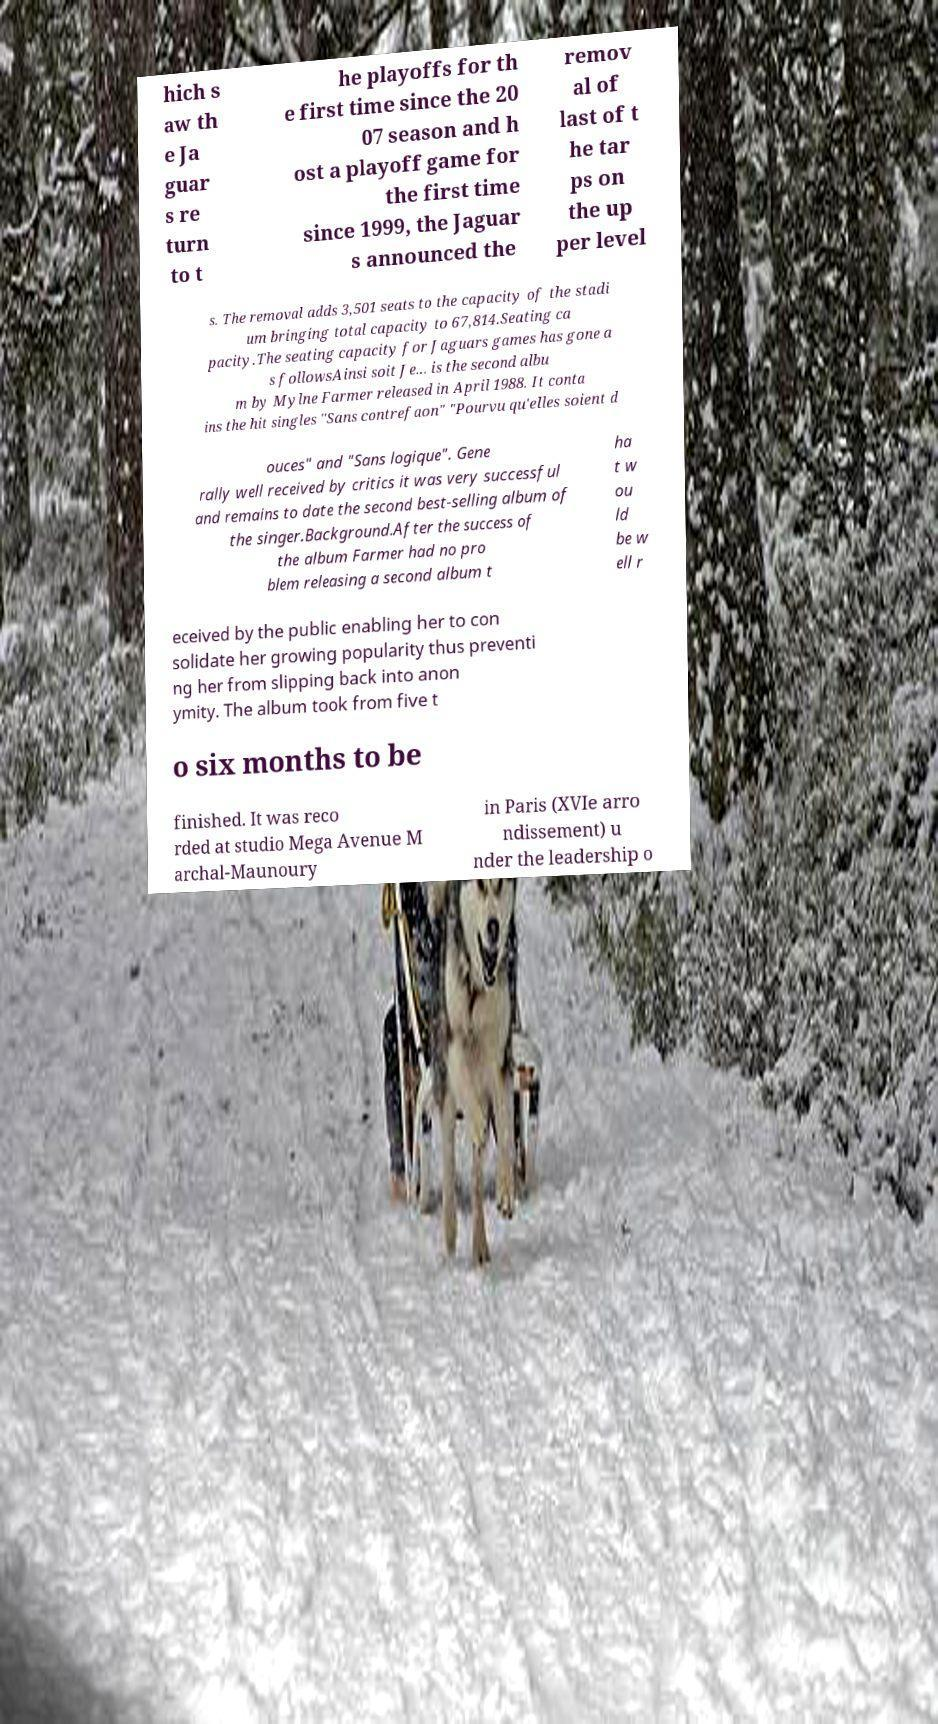Could you assist in decoding the text presented in this image and type it out clearly? hich s aw th e Ja guar s re turn to t he playoffs for th e first time since the 20 07 season and h ost a playoff game for the first time since 1999, the Jaguar s announced the remov al of last of t he tar ps on the up per level s. The removal adds 3,501 seats to the capacity of the stadi um bringing total capacity to 67,814.Seating ca pacity.The seating capacity for Jaguars games has gone a s followsAinsi soit Je... is the second albu m by Mylne Farmer released in April 1988. It conta ins the hit singles "Sans contrefaon" "Pourvu qu'elles soient d ouces" and "Sans logique". Gene rally well received by critics it was very successful and remains to date the second best-selling album of the singer.Background.After the success of the album Farmer had no pro blem releasing a second album t ha t w ou ld be w ell r eceived by the public enabling her to con solidate her growing popularity thus preventi ng her from slipping back into anon ymity. The album took from five t o six months to be finished. It was reco rded at studio Mega Avenue M archal-Maunoury in Paris (XVIe arro ndissement) u nder the leadership o 